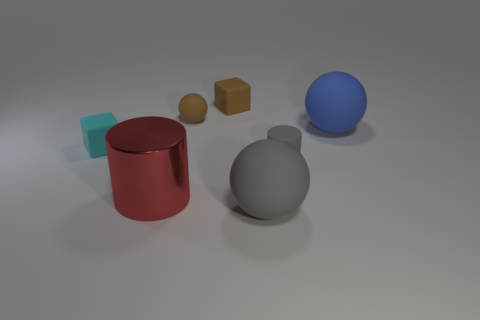Subtract all brown balls. How many balls are left? 2 Add 2 small cyan metal balls. How many objects exist? 9 Subtract all cyan blocks. How many blocks are left? 1 Subtract 0 cyan balls. How many objects are left? 7 Subtract all cylinders. How many objects are left? 5 Subtract 2 cylinders. How many cylinders are left? 0 Subtract all green balls. Subtract all green cylinders. How many balls are left? 3 Subtract all large cyan shiny objects. Subtract all small gray things. How many objects are left? 6 Add 4 small matte blocks. How many small matte blocks are left? 6 Add 3 large purple blocks. How many large purple blocks exist? 3 